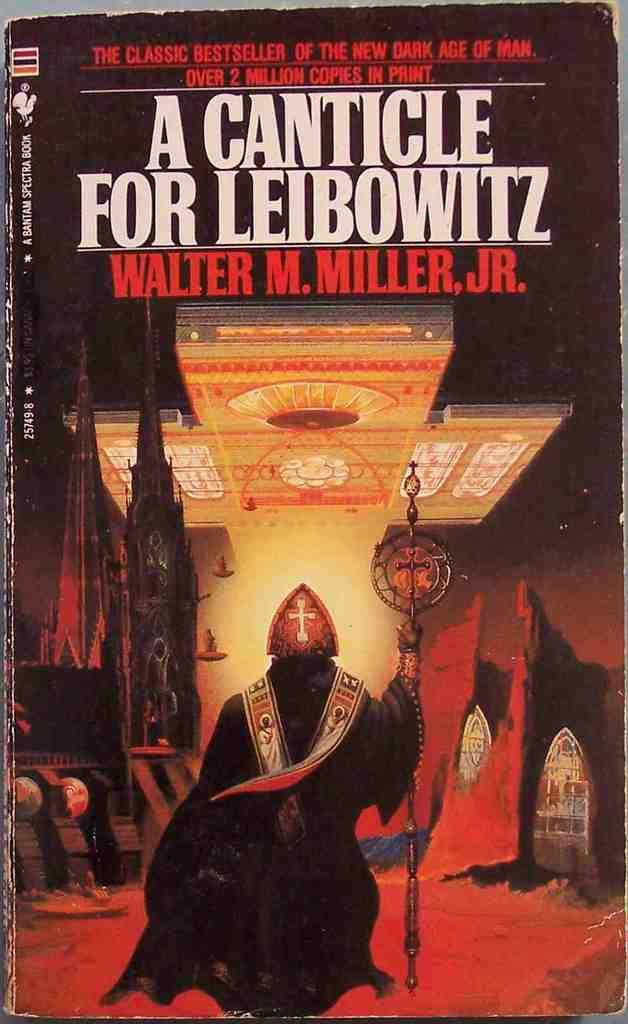<image>
Present a compact description of the photo's key features. The book A canticle for leibowitz is shown 